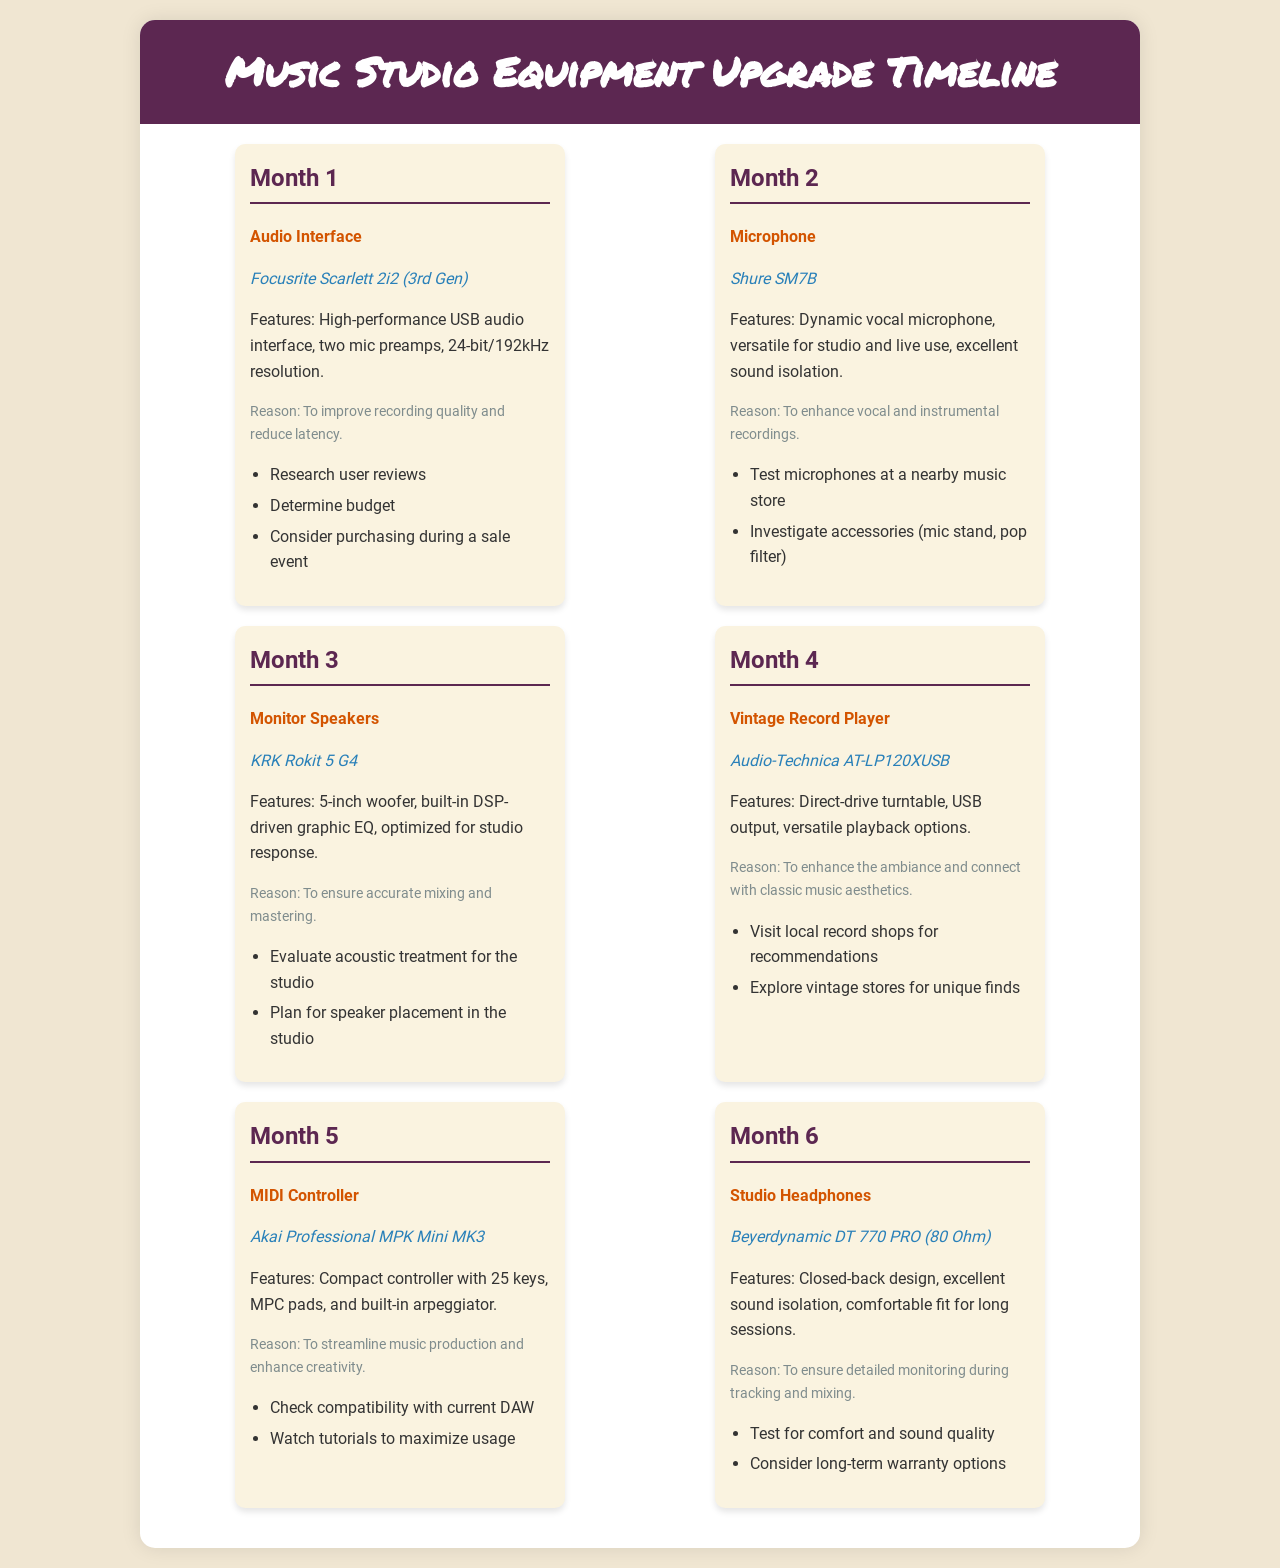What is the focus of Month 1? Month 1 features an audio interface upgrade, specifically the Focusrite Scarlett 2i2 (3rd Gen).
Answer: Audio Interface What model is being upgraded in Month 2? In Month 2, the microphone being upgraded is the Shure SM7B.
Answer: Shure SM7B What is the reason for upgrading to the KRK Rokit 5 G4 in Month 3? The reason for upgrading to the KRK Rokit 5 G4 is to ensure accurate mixing and mastering.
Answer: Accurate mixing and mastering Which vintage record player is scheduled for Month 4? The vintage record player scheduled for Month 4 is the Audio-Technica AT-LP120XUSB.
Answer: Audio-Technica AT-LP120XUSB How many keys does the MIDI Controller have in Month 5? The MIDI controller in Month 5, the Akai Professional MPK Mini MK3, has 25 keys.
Answer: 25 keys What type of headphones is planned for Month 6? The type of headphones planned for Month 6 is studio headphones.
Answer: Studio Headphones In which month is the vintage record player scheduled? The vintage record player is scheduled for Month 4.
Answer: Month 4 What is a feature of the Beyerdynamic DT 770 PRO headphones? A feature of the Beyerdynamic DT 770 PRO headphones is excellent sound isolation.
Answer: Excellent sound isolation 